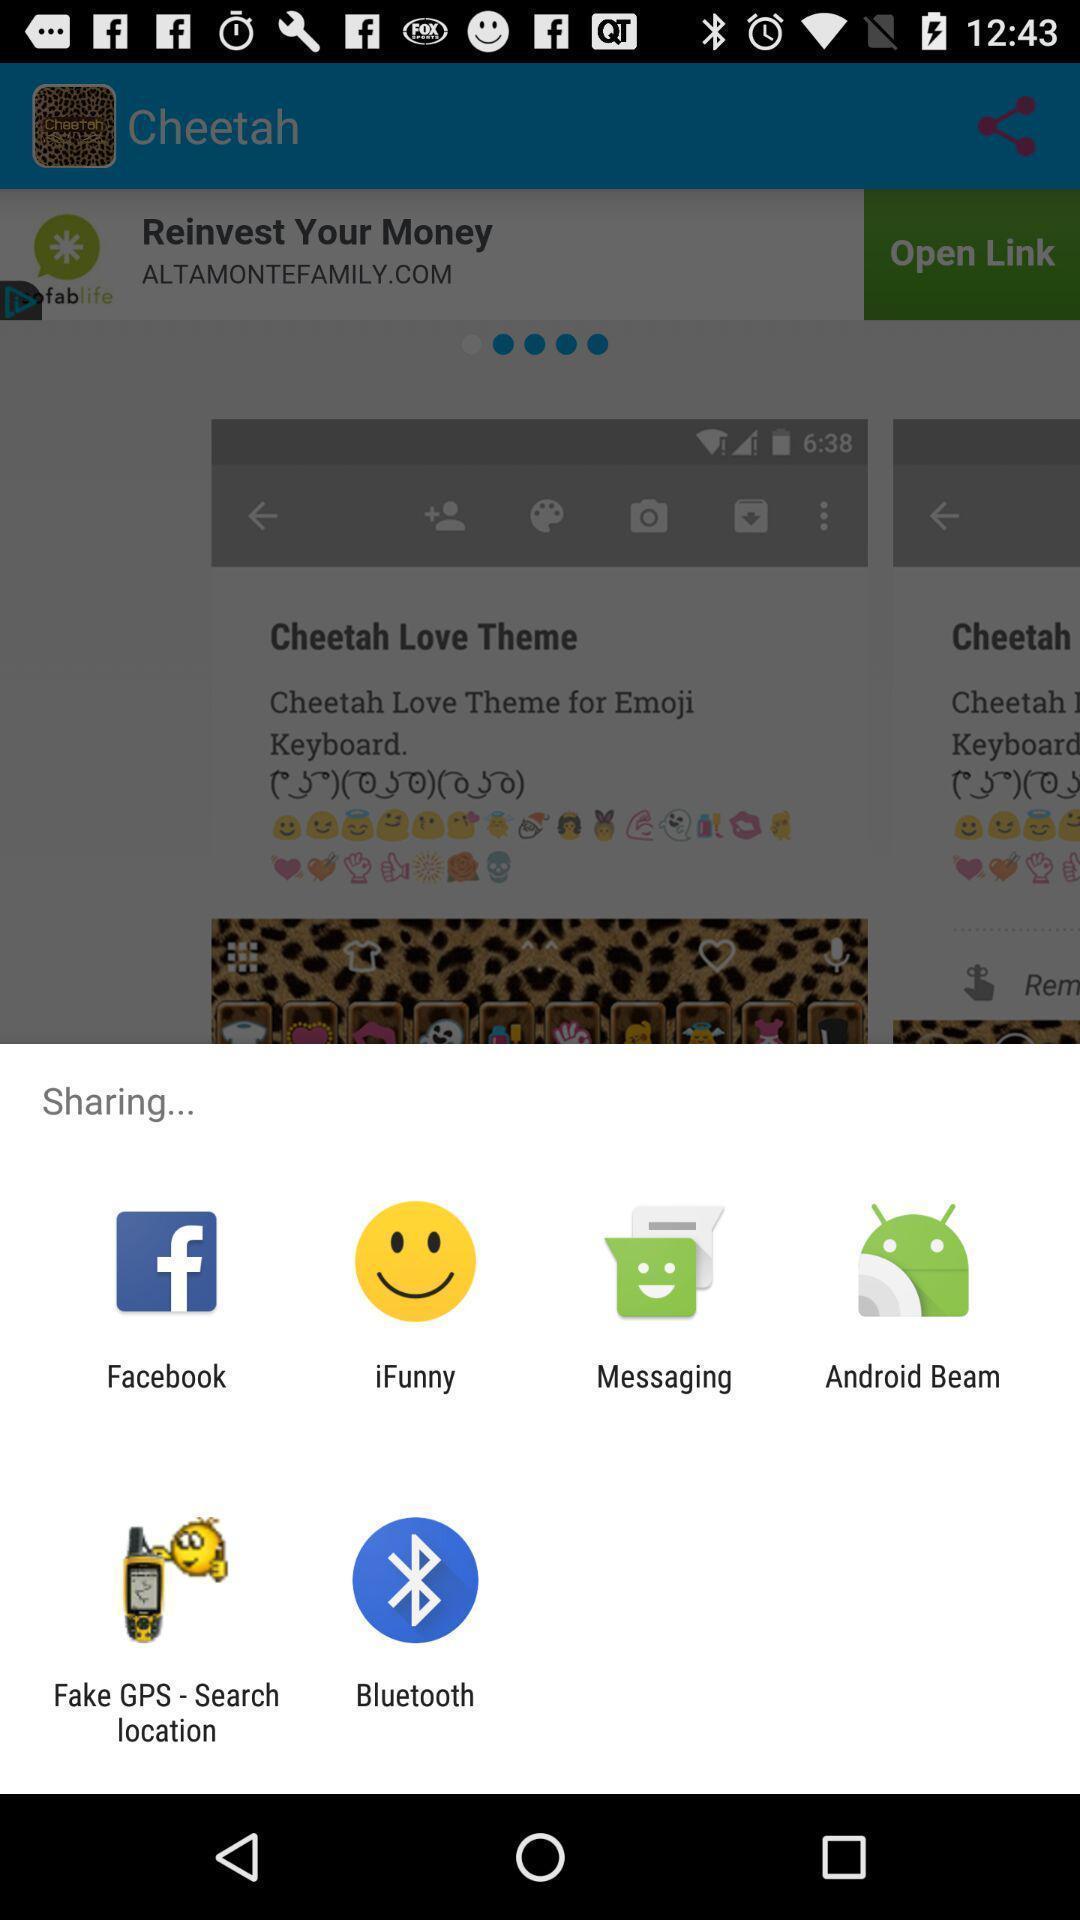Summarize the main components in this picture. Pop-up showing different share options. 